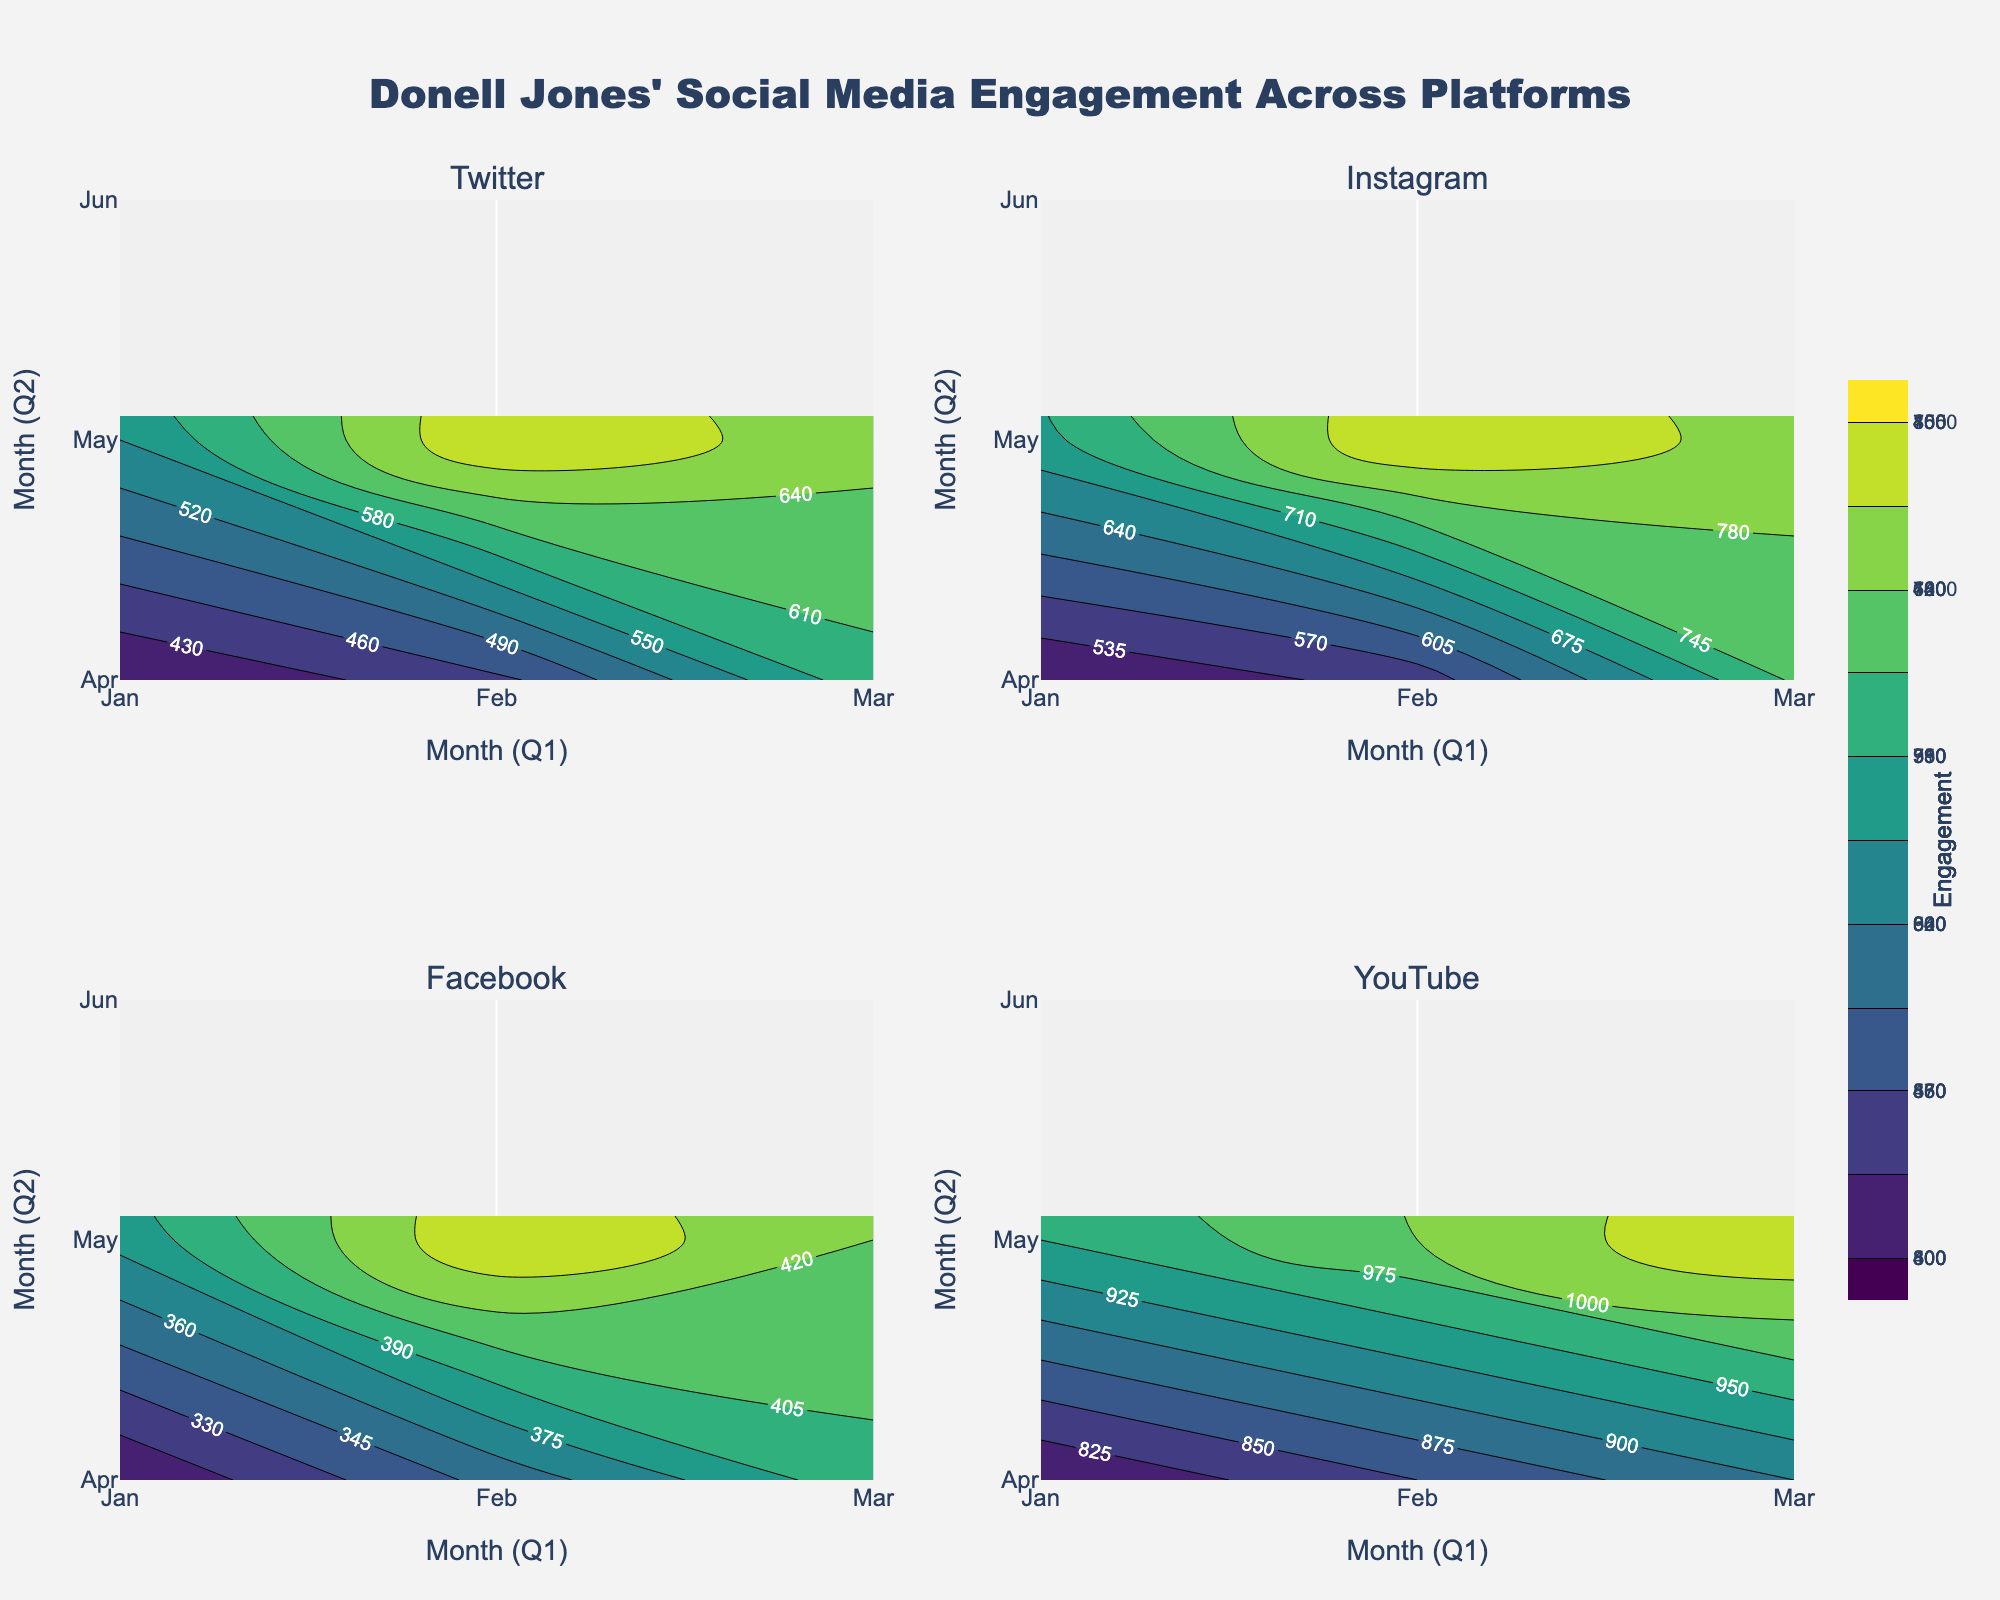What's the title of the figure? The title is usually positioned at the top center of the figure. In this case, it says, "Donell Jones' Social Media Engagement Across Platforms"
Answer: Donell Jones' Social Media Engagement Across Platforms Which platform has the highest engagement in May? By looking at the contours and the color intensity for each platform in May, YouTube shows the highest engagement in May as indicated by the darkest color in the contour plot for YouTube in the figure.
Answer: YouTube What is the range of engagement values shown in the Facebook subplot? By focusing on the colorbar on the right side that corresponds to the Facebook subplot, you can see the minimum value (300) and the maximum value (450).
Answer: 300-450 Which platform shows a more significant increase in engagement from January to June? Compare the contour plots of each platform over the six months. YouTube shows a clear and steady increase in engagement much larger than the other platforms, indicating a more significant increase from January to June.
Answer: YouTube What month sees the highest engagement for Donell Jones on Instagram? By observing the darkest color intensity in the Instagram subplot and reading along the x-axis, you can deduce that May had the highest engagement on Instagram.
Answer: May How does Twitter's engagement in March compare to Facebook's engagement in June? By checking the engagement values associated with March for Twitter and June for Facebook, Twitter's engagement in March (600) is higher than Facebook's engagement in June (420).
Answer: Twitter is higher What is the contour interval for Instagram’s engagement plot? Contour intervals can be deduced from the contour line spacing and the colorbar. Here, the interval shown for Instagram appears to be in steps of 50, starting from the minimum to the maximum engagement value.
Answer: 50 Between Instagram and Facebook, which platform showed a more pronounced engagement increase during the second quarter (April to June)? The color gradients from April to June are steeper for Instagram than for Facebook, indicating a more pronounced increase in engagement for Instagram in this period.
Answer: Instagram What general trend is observed in YouTube engagement over the six months? The contour plot for YouTube consistently shows color intensification from January to June, indicating a continuous increase in engagement over the six months.
Answer: Continuous increase For which platforms does the engagement have a larger dispersion between the first and second quarter? Analyze the contour differences between the first three months (Q1) and the last three months (Q2) across platforms. YouTube shows the largest dispersion as the change from January to June is more significant than for other platforms.
Answer: YouTube 